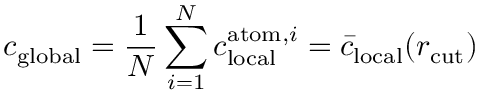<formula> <loc_0><loc_0><loc_500><loc_500>c _ { g l o b a l } = \frac { 1 } { N } \sum _ { i = 1 } ^ { N } c _ { l o c a l } ^ { a t o m , i } = \bar { c } _ { l o c a l } ( r _ { c u t } )</formula> 